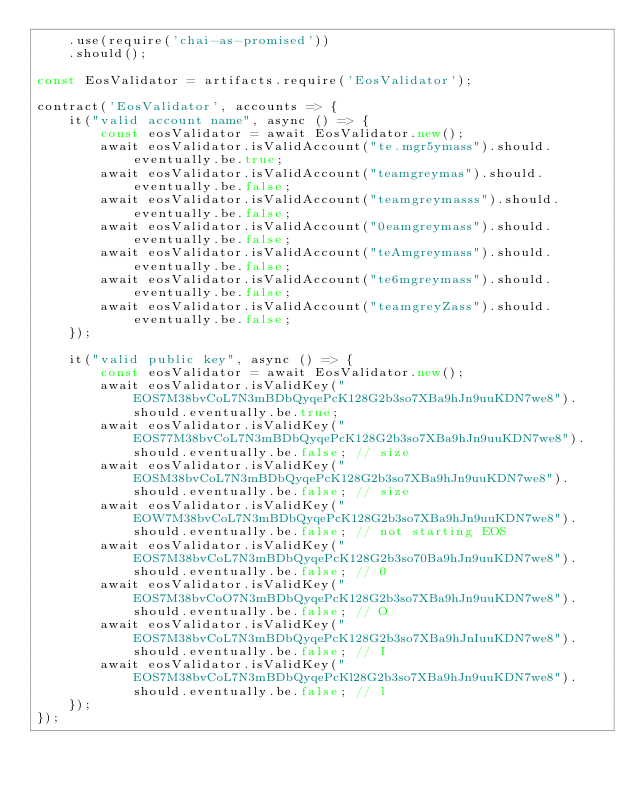<code> <loc_0><loc_0><loc_500><loc_500><_JavaScript_>    .use(require('chai-as-promised'))
    .should();

const EosValidator = artifacts.require('EosValidator');

contract('EosValidator', accounts => {
    it("valid account name", async () => {
        const eosValidator = await EosValidator.new();
        await eosValidator.isValidAccount("te.mgr5ymass").should.eventually.be.true;
        await eosValidator.isValidAccount("teamgreymas").should.eventually.be.false;
        await eosValidator.isValidAccount("teamgreymasss").should.eventually.be.false;
        await eosValidator.isValidAccount("0eamgreymass").should.eventually.be.false;
        await eosValidator.isValidAccount("teAmgreymass").should.eventually.be.false;
        await eosValidator.isValidAccount("te6mgreymass").should.eventually.be.false;
        await eosValidator.isValidAccount("teamgreyZass").should.eventually.be.false;
    });

    it("valid public key", async () => {
        const eosValidator = await EosValidator.new();
        await eosValidator.isValidKey("EOS7M38bvCoL7N3mBDbQyqePcK128G2b3so7XBa9hJn9uuKDN7we8").should.eventually.be.true;
        await eosValidator.isValidKey("EOS77M38bvCoL7N3mBDbQyqePcK128G2b3so7XBa9hJn9uuKDN7we8").should.eventually.be.false; // size
        await eosValidator.isValidKey("EOSM38bvCoL7N3mBDbQyqePcK128G2b3so7XBa9hJn9uuKDN7we8").should.eventually.be.false; // size
        await eosValidator.isValidKey("EOW7M38bvCoL7N3mBDbQyqePcK128G2b3so7XBa9hJn9uuKDN7we8").should.eventually.be.false; // not starting EOS
        await eosValidator.isValidKey("EOS7M38bvCoL7N3mBDbQyqePcK128G2b3so70Ba9hJn9uuKDN7we8").should.eventually.be.false; // 0
        await eosValidator.isValidKey("EOS7M38bvCoO7N3mBDbQyqePcK128G2b3so7XBa9hJn9uuKDN7we8").should.eventually.be.false; // O
        await eosValidator.isValidKey("EOS7M38bvCoL7N3mBDbQyqePcK128G2b3so7XBa9hJnIuuKDN7we8").should.eventually.be.false; // I
        await eosValidator.isValidKey("EOS7M38bvCoL7N3mBDbQyqePcKl28G2b3so7XBa9hJn9uuKDN7we8").should.eventually.be.false; // l
    });
});</code> 